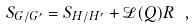<formula> <loc_0><loc_0><loc_500><loc_500>S _ { G / G ^ { \prime } } = S _ { H / H ^ { \prime } } + \mathcal { L } ( Q ) R \ ,</formula> 